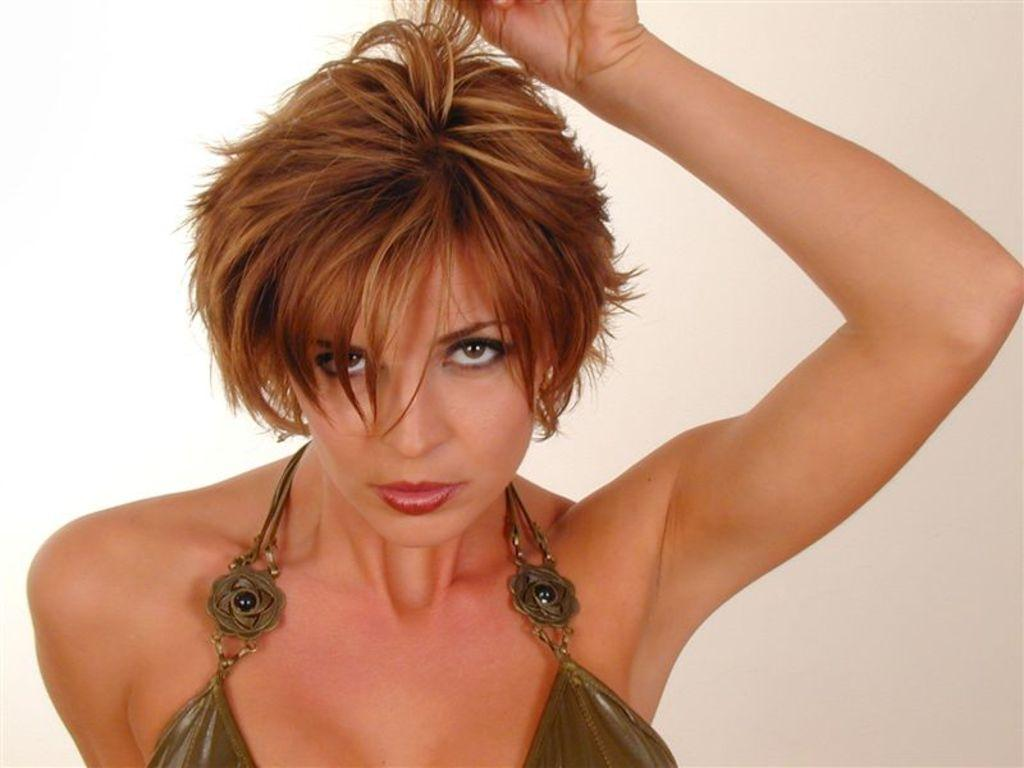What color is the background of the image? The background of the image is cream in color. Who or what is the main subject in the image? There is a woman in the middle of the image. Can you describe the woman's appearance? The woman has short hair. What type of truck is parked next to the woman in the image? There is no truck present in the image; it only features a woman with short hair against a cream-colored background. 